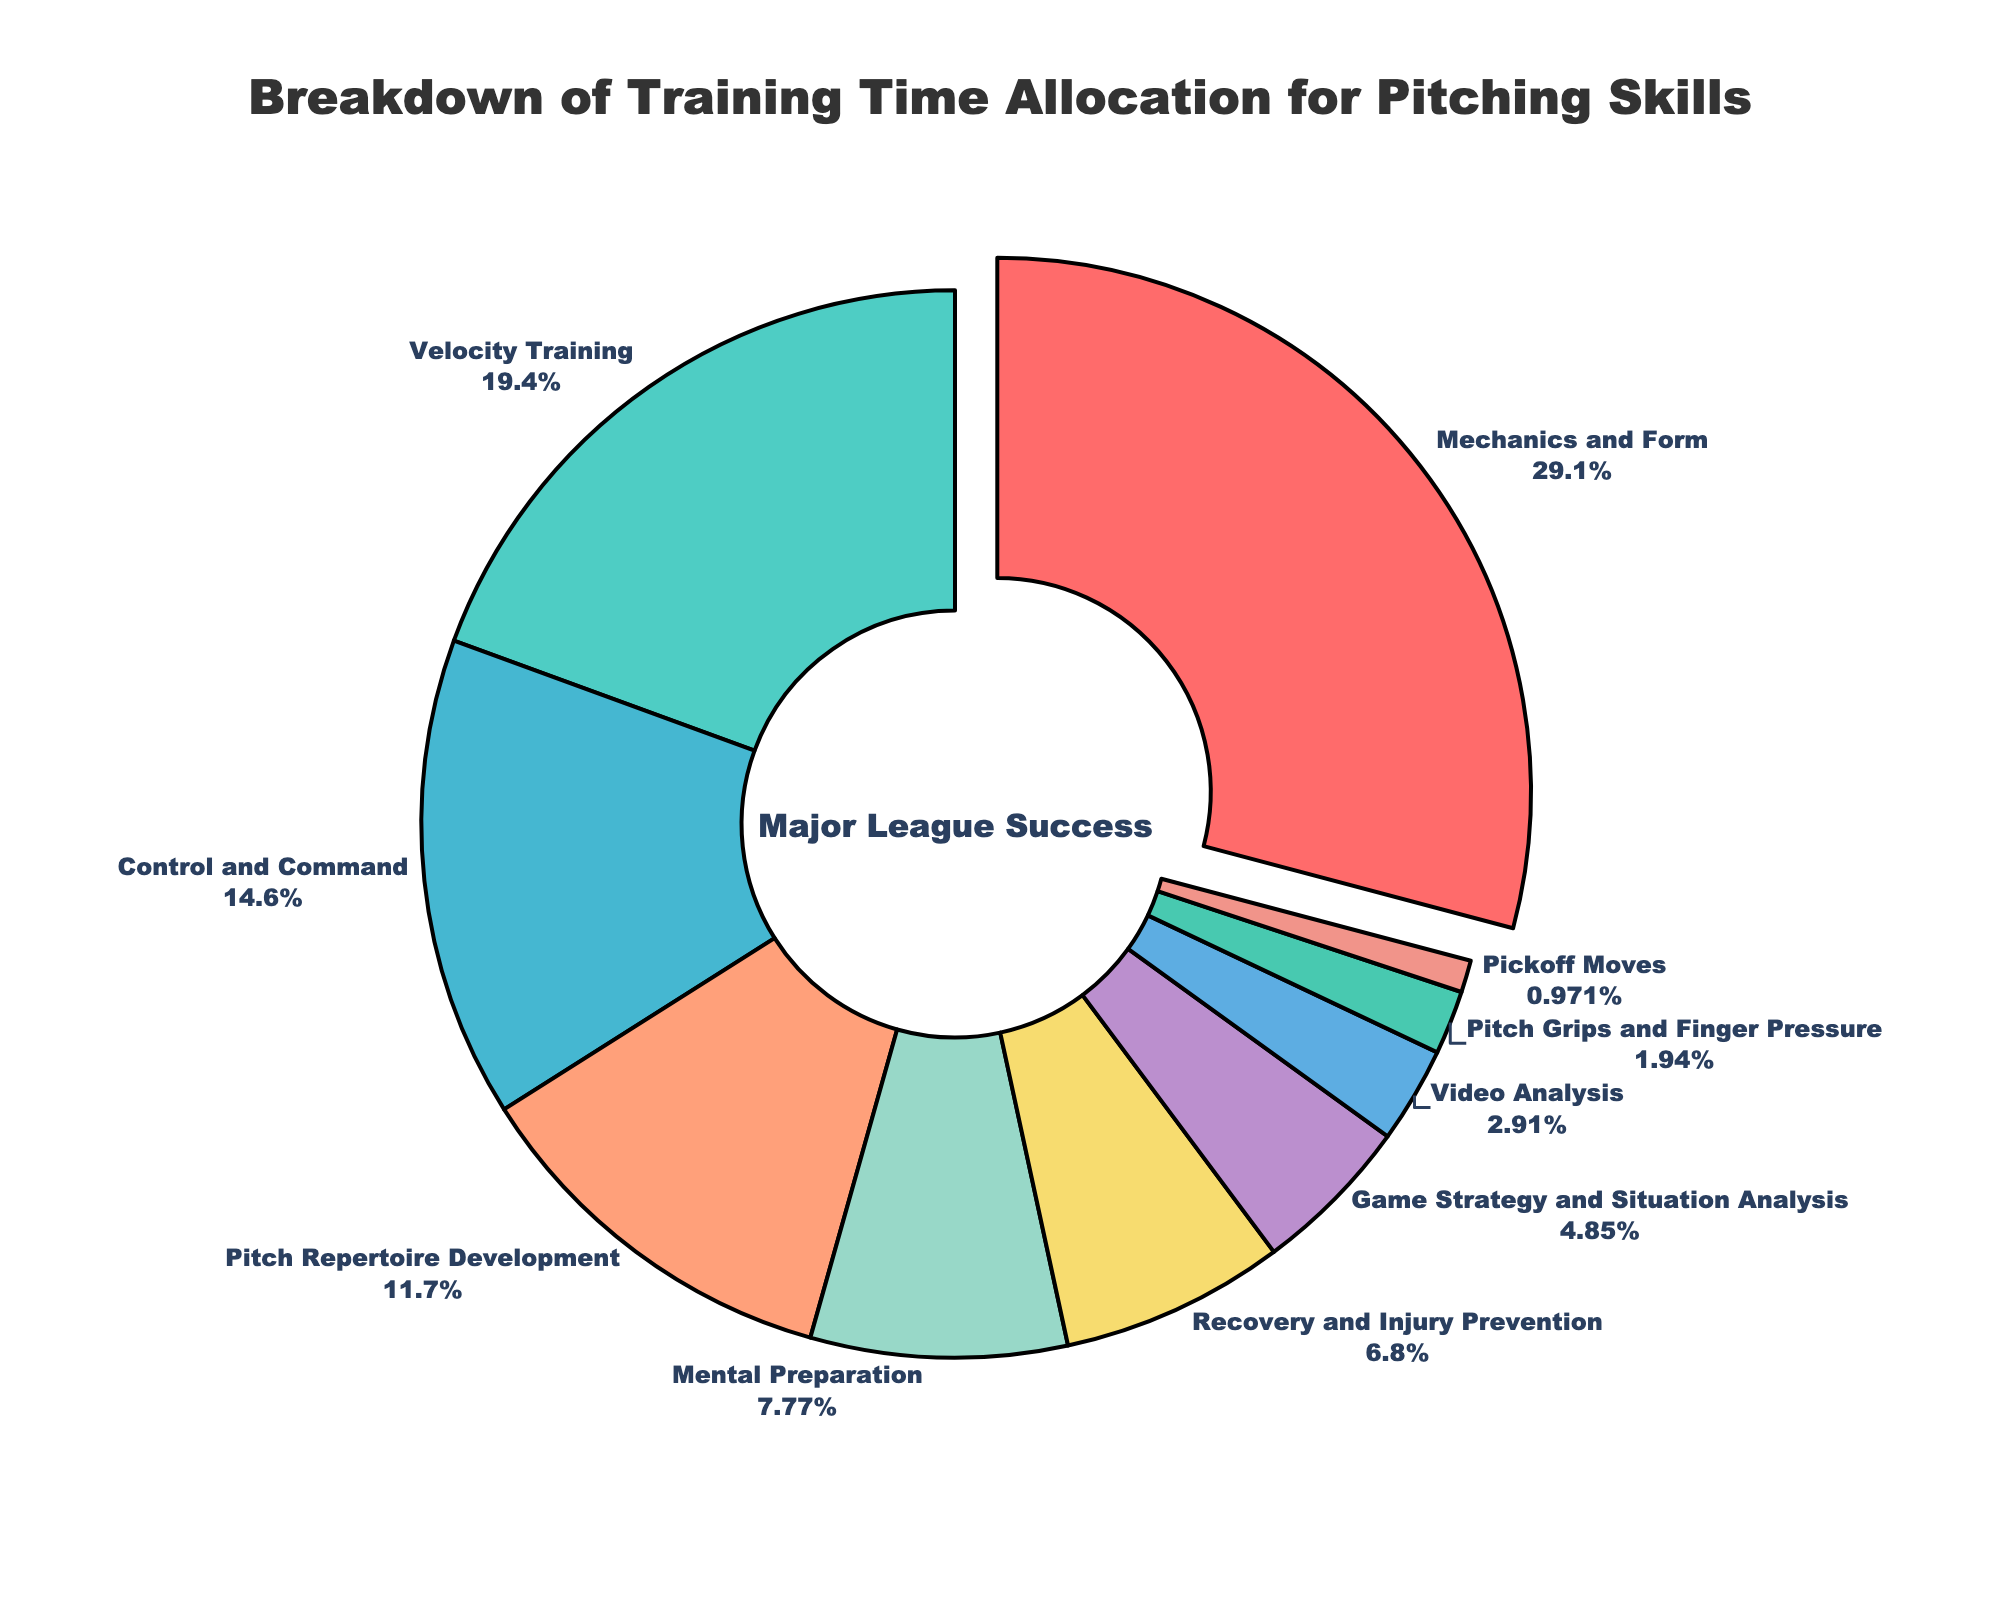What's the skill with the highest percentage of training time allocated? The figure clearly shows that "Mechanics and Form" takes up the largest portion of the pie chart.
Answer: Mechanics and Form What percentage of training time is allocated to Velocity Training? Referring to the figure, the section labeled "Velocity Training" shows the percentage.
Answer: 20% Which skill has a higher percentage of training time: Mental Preparation or Control and Command? By comparing the two sections labeled "Mental Preparation" and "Control and Command," it is clear that "Control and Command" has a higher percentage.
Answer: Control and Command What's the combined percentage of time spent on Mechanics and Form, and Velocity Training? Adding the percentages of "Mechanics and Form" (30%) and "Velocity Training" (20%) gives: 30 + 20 = 50
Answer: 50% What is the least emphasized skill in terms of training time? The smallest segment in the pie chart is labeled "Pickoff Moves."
Answer: Pickoff Moves How much more training time is allocated to Pitch Repertoire Development than Recovery and Injury Prevention? Pitch Repertoire Development is 12%, and Recovery and Injury Prevention is 7%. The difference is: 12 - 7 = 5
Answer: 5% What skill takes up a portion of the pie chart that is about half the size of Velocity Training? The pie chart shows that Control and Command (15%) is approximately half the size of Velocity Training (20%).
Answer: Control and Command What's the total percentage of time spent on skills related to improving physical mechanics (Mechanics and Form, Velocity Training, and Control and Command)? Adding the percentages of "Mechanics and Form" (30%), "Velocity Training" (20%), and "Control and Command" (15%) gives a total of: 30 + 20 + 15 = 65
Answer: 65% Which is greater: The combined percentage of time spent on Mental Preparation and Video Analysis, or the percentage spent on Game Strategy and Situation Analysis? Mental Preparation is 8%, and Video Analysis is 3%, the combined is: 8 + 3 = 11. Game Strategy and Situation Analysis is 5%. So, 11 is greater than 5.
Answer: Mental Preparation and Video Analysis What is the visual marker that highlights the largest segment of the pie chart? The largest segment "Mechanics and Form" has a slight "pull" effect, visually setting it apart from the other segments.
Answer: Pull effect 